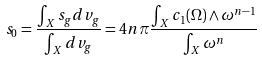<formula> <loc_0><loc_0><loc_500><loc_500>s _ { 0 } = \frac { \int _ { X } s _ { g } d v _ { g } } { \int _ { X } d v _ { g } } = 4 n \pi \frac { \int _ { X } c _ { 1 } ( \Omega ) \wedge \omega ^ { n - 1 } } { \int _ { X } \omega ^ { n } }</formula> 